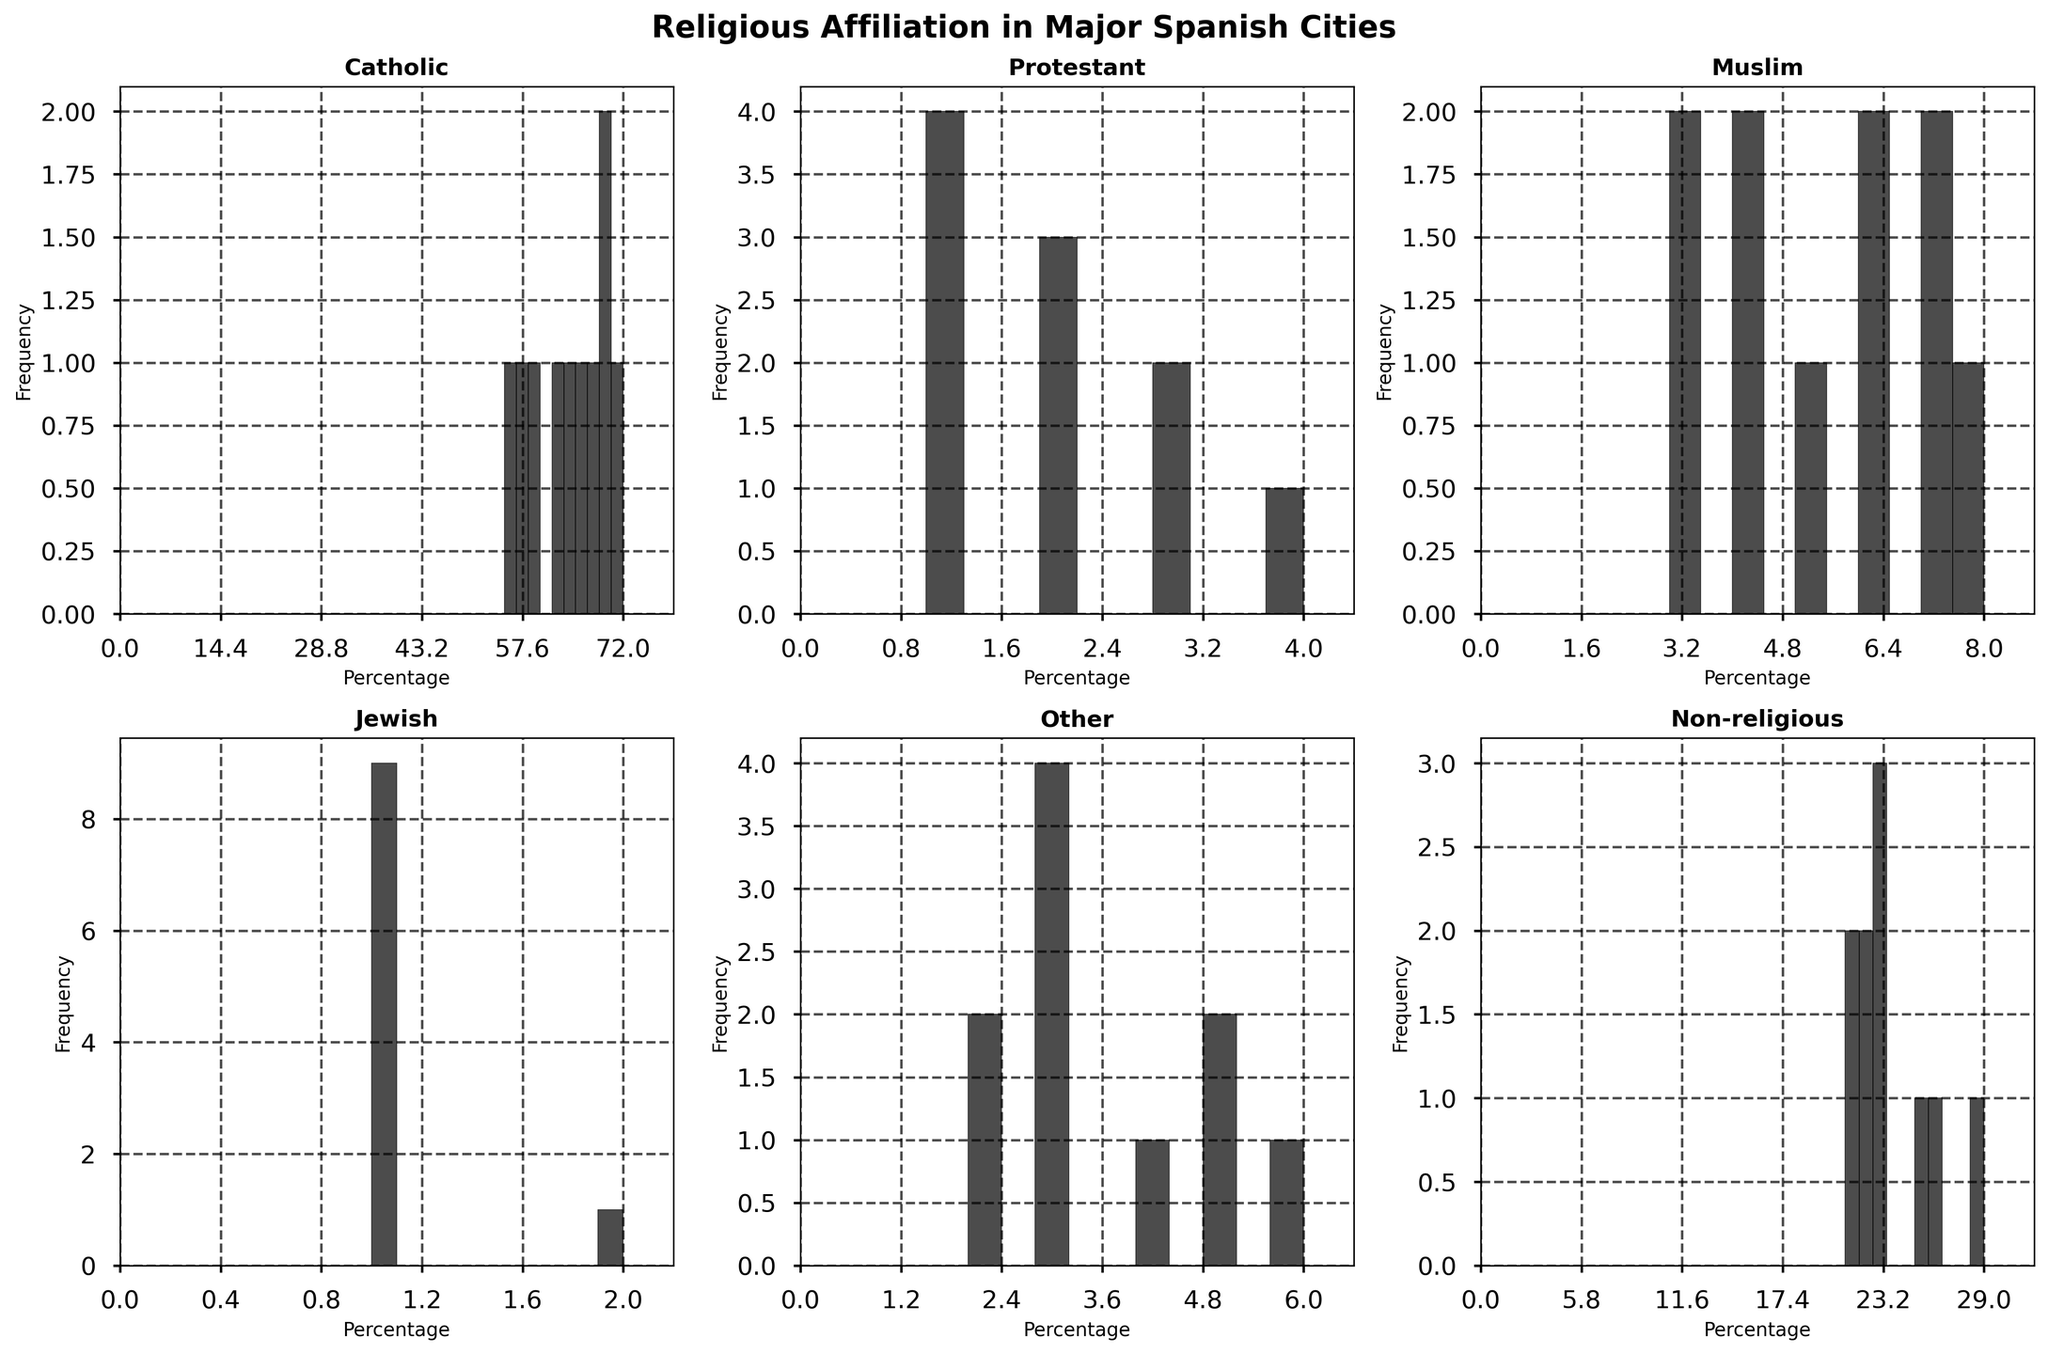Which city has the highest percentage of Catholics? By looking at the histogram for Catholics, Santiago de Compostela has the highest bar around 72%.
Answer: Santiago de Compostela What is the average percentage of Non-religious people across all cities? By observing the histogram for Non-religious people, the values are 23, 26, 25, 22, 29, 22, 21, 21, 23, 23. Adding these and dividing by 10 (the number of cities) gives (23+26+25+22+29+22+21+21+23+23)/10 = 23.5
Answer: 23.5 Which city shows the least variation in religious communities? Comparing histograms, Santiago de Compostela and Toledo have consistently high percentages of Catholics and relatively consistent low percentages in other religions.
Answer: Santiago de Compostela or Toledo How many bins are used in the histogram for the Muslim percentage? Counting the bars in the histogram for Muslim percentage, there are 8 bins used.
Answer: 8 Which religion shows the most even distribution across cities? Comparing the spreads of the histograms, the 'Other' religion histogram appears most evenly spread.
Answer: Other Is the median percentage of Protestants greater than 2? Listing the histogram bins for Protestants shows values 3, 4, 2, 1, 3, 2, 1, 1, 1, 2. The median value here is the average of the 5th and 6th values (both 2), thus 2.
Answer: No Which city has both a high percentage of Catholics and a high percentage of Non-religious people? Observing both histograms for Catholics and Non-religious, Madrid, Barcelona, and Valencia have noticeable values in both categories; however, Madrid has a high of 60% Catholics and 23% Non-religious.
Answer: Madrid What is the percentage difference between Catholics in Seville and Bilbao? Seville has 68% and Bilbao has 58%, so the difference is 68 - 58 = 10%.
Answer: 10 Do Muslim percentages exceed Protestant percentages in Valencia? The histogram shows the Muslim percentage for Valencia is higher at approximately 6% compared to ~2% for Protestants.
Answer: Yes Which group has the least number of cities with over 5% representation? The 'Jewish' histogram indicates only two cities (out of 10) have more than 5%, evident in Barcelona. Other groups have more cities over 5%.
Answer: Jewish 